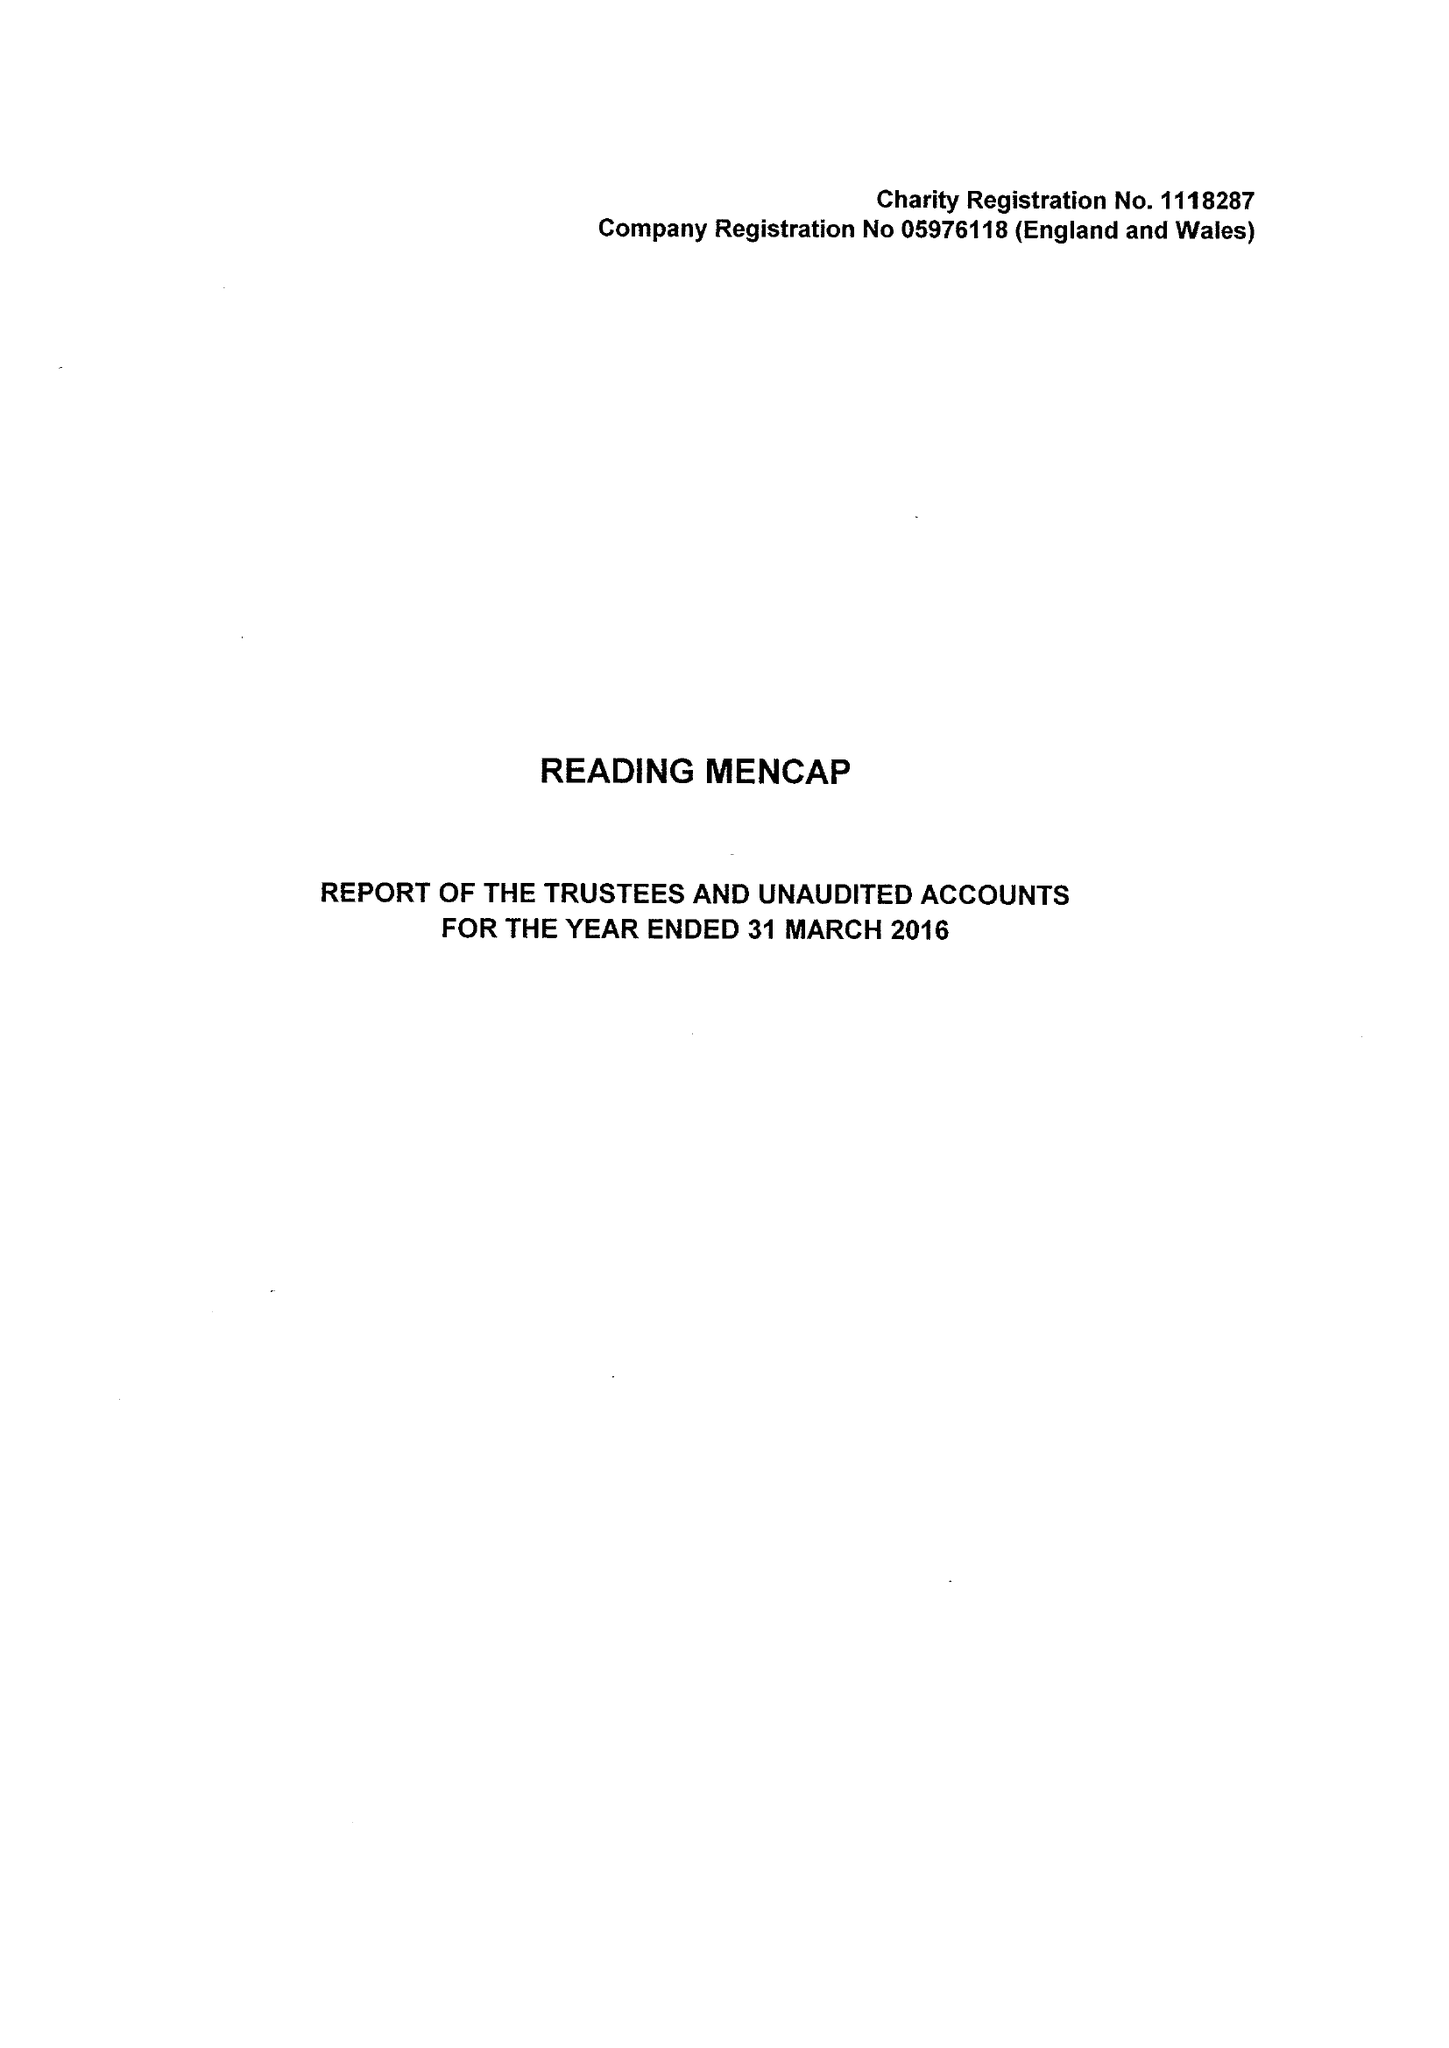What is the value for the report_date?
Answer the question using a single word or phrase. 2016-03-31 